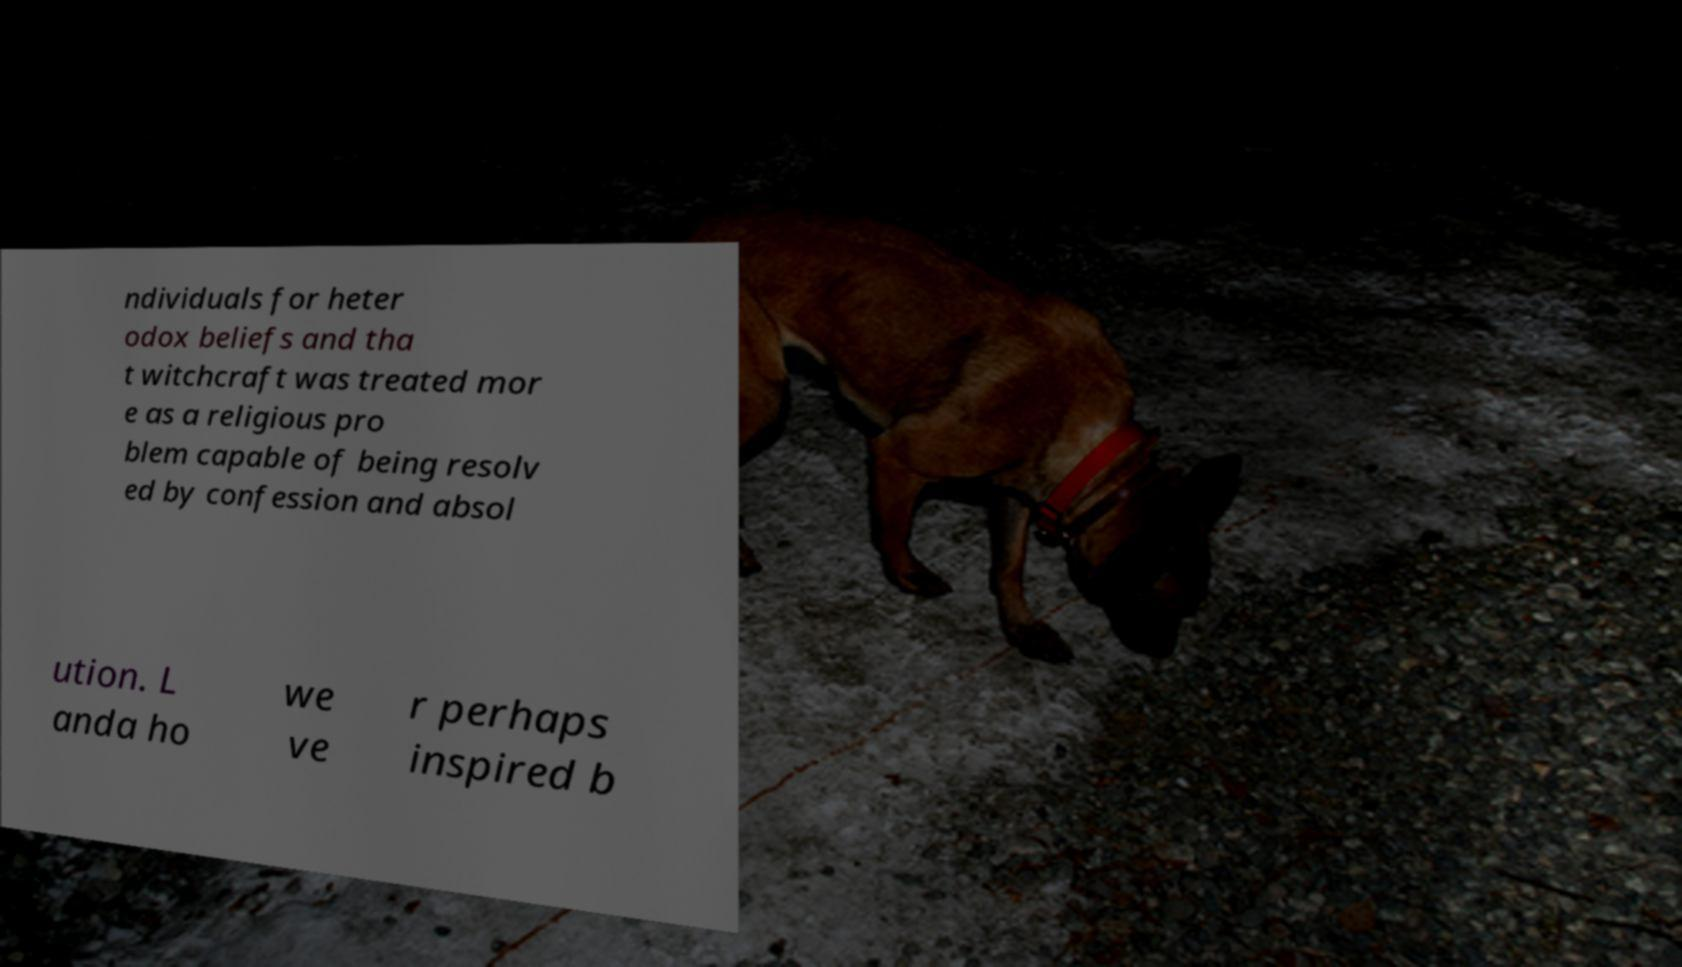For documentation purposes, I need the text within this image transcribed. Could you provide that? ndividuals for heter odox beliefs and tha t witchcraft was treated mor e as a religious pro blem capable of being resolv ed by confession and absol ution. L anda ho we ve r perhaps inspired b 